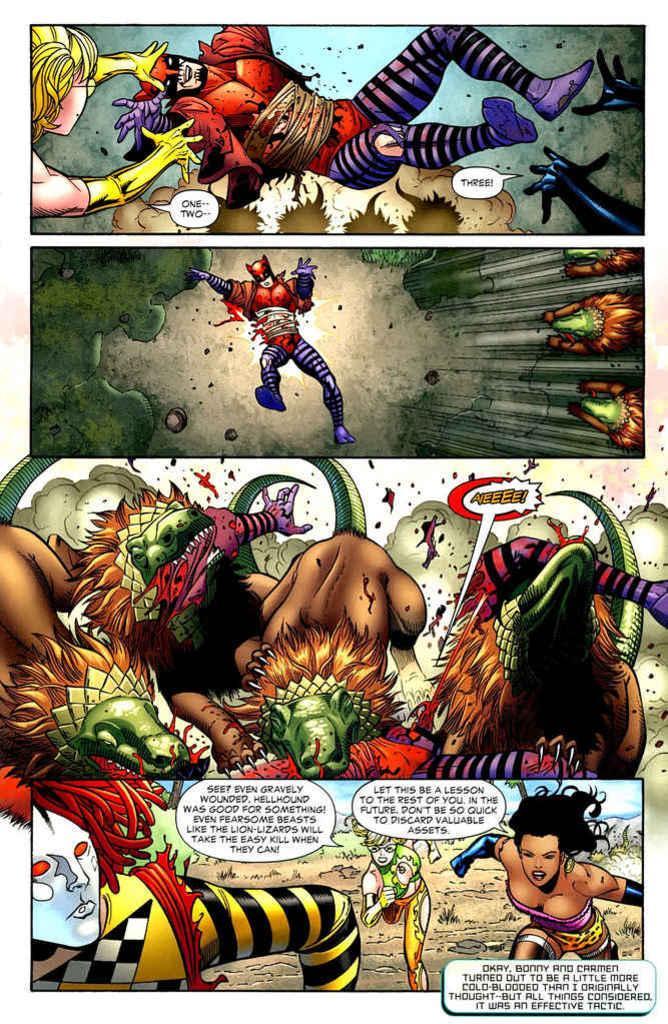Can you describe this image briefly? In this picture there is a poster in the center of the image, which includes cartoon characters. 